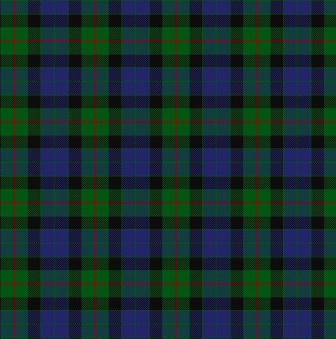If you had to create a fictional world where the essence of this tartan pattern comes to life, what would it be like? Welcome to the vibrant world of Tartanarii, a fantastical realm where the essence of this tartan pattern weaves through every aspect of life. In Tartanarii, the land itself is a living tapestry of plaid, with rolling hills of green and blue intersected by rivers of black and red. Structures are built using interlocking cubes that echo the pattern, creating harmonious and colorful cities. Inhabitants of Tartanarii wear garments adorned with elaborate tartan designs, each symbolizing their lineage, craft, or allegiance. Magic here is interwoven with the fabric of reality, with master weavers known as Patternalists who can manipulate the patterns to alter time and space, heal wounds, or summon ethereal creatures. Festivals are vibrant displays of choreographed dances and music that mirror the geometric symmetry of tartan, celebrating the unity and diversity within their culture. This world is a celebration of harmony, order, and aesthetic beauty, where every thread tells a story and every pattern holds power. 